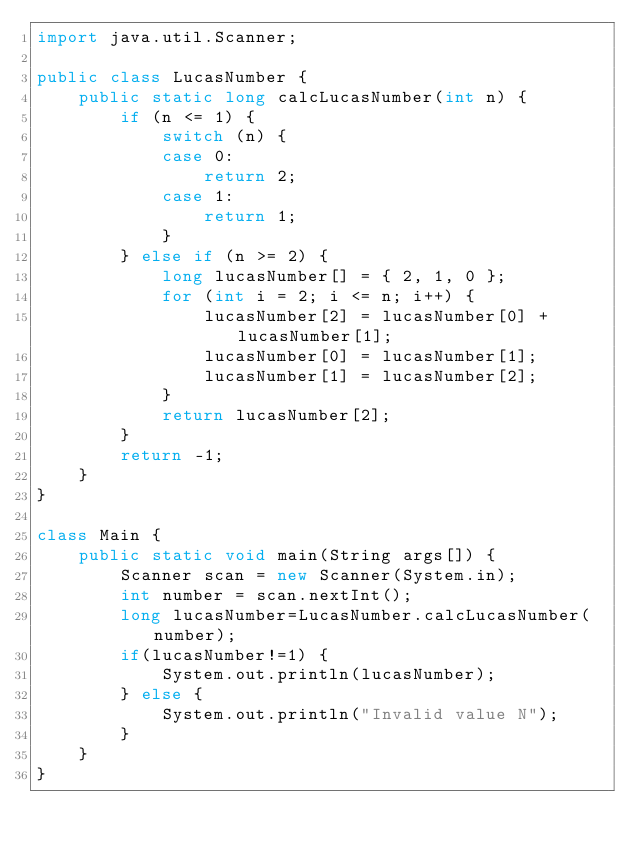Convert code to text. <code><loc_0><loc_0><loc_500><loc_500><_Java_>import java.util.Scanner;

public class LucasNumber {
	public static long calcLucasNumber(int n) {
		if (n <= 1) {
			switch (n) {
			case 0:
				return 2;
			case 1:
				return 1;
			}
		} else if (n >= 2) {
			long lucasNumber[] = { 2, 1, 0 };
			for (int i = 2; i <= n; i++) {
				lucasNumber[2] = lucasNumber[0] + lucasNumber[1];
				lucasNumber[0] = lucasNumber[1];
				lucasNumber[1] = lucasNumber[2];
			}
			return lucasNumber[2];
		}
		return -1;
	}
}

class Main {
	public static void main(String args[]) {
		Scanner scan = new Scanner(System.in);
		int number = scan.nextInt();
		long lucasNumber=LucasNumber.calcLucasNumber(number);
		if(lucasNumber!=1) {
			System.out.println(lucasNumber);
		} else {
			System.out.println("Invalid value N");
		}
	}
}</code> 